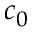<formula> <loc_0><loc_0><loc_500><loc_500>c _ { 0 }</formula> 